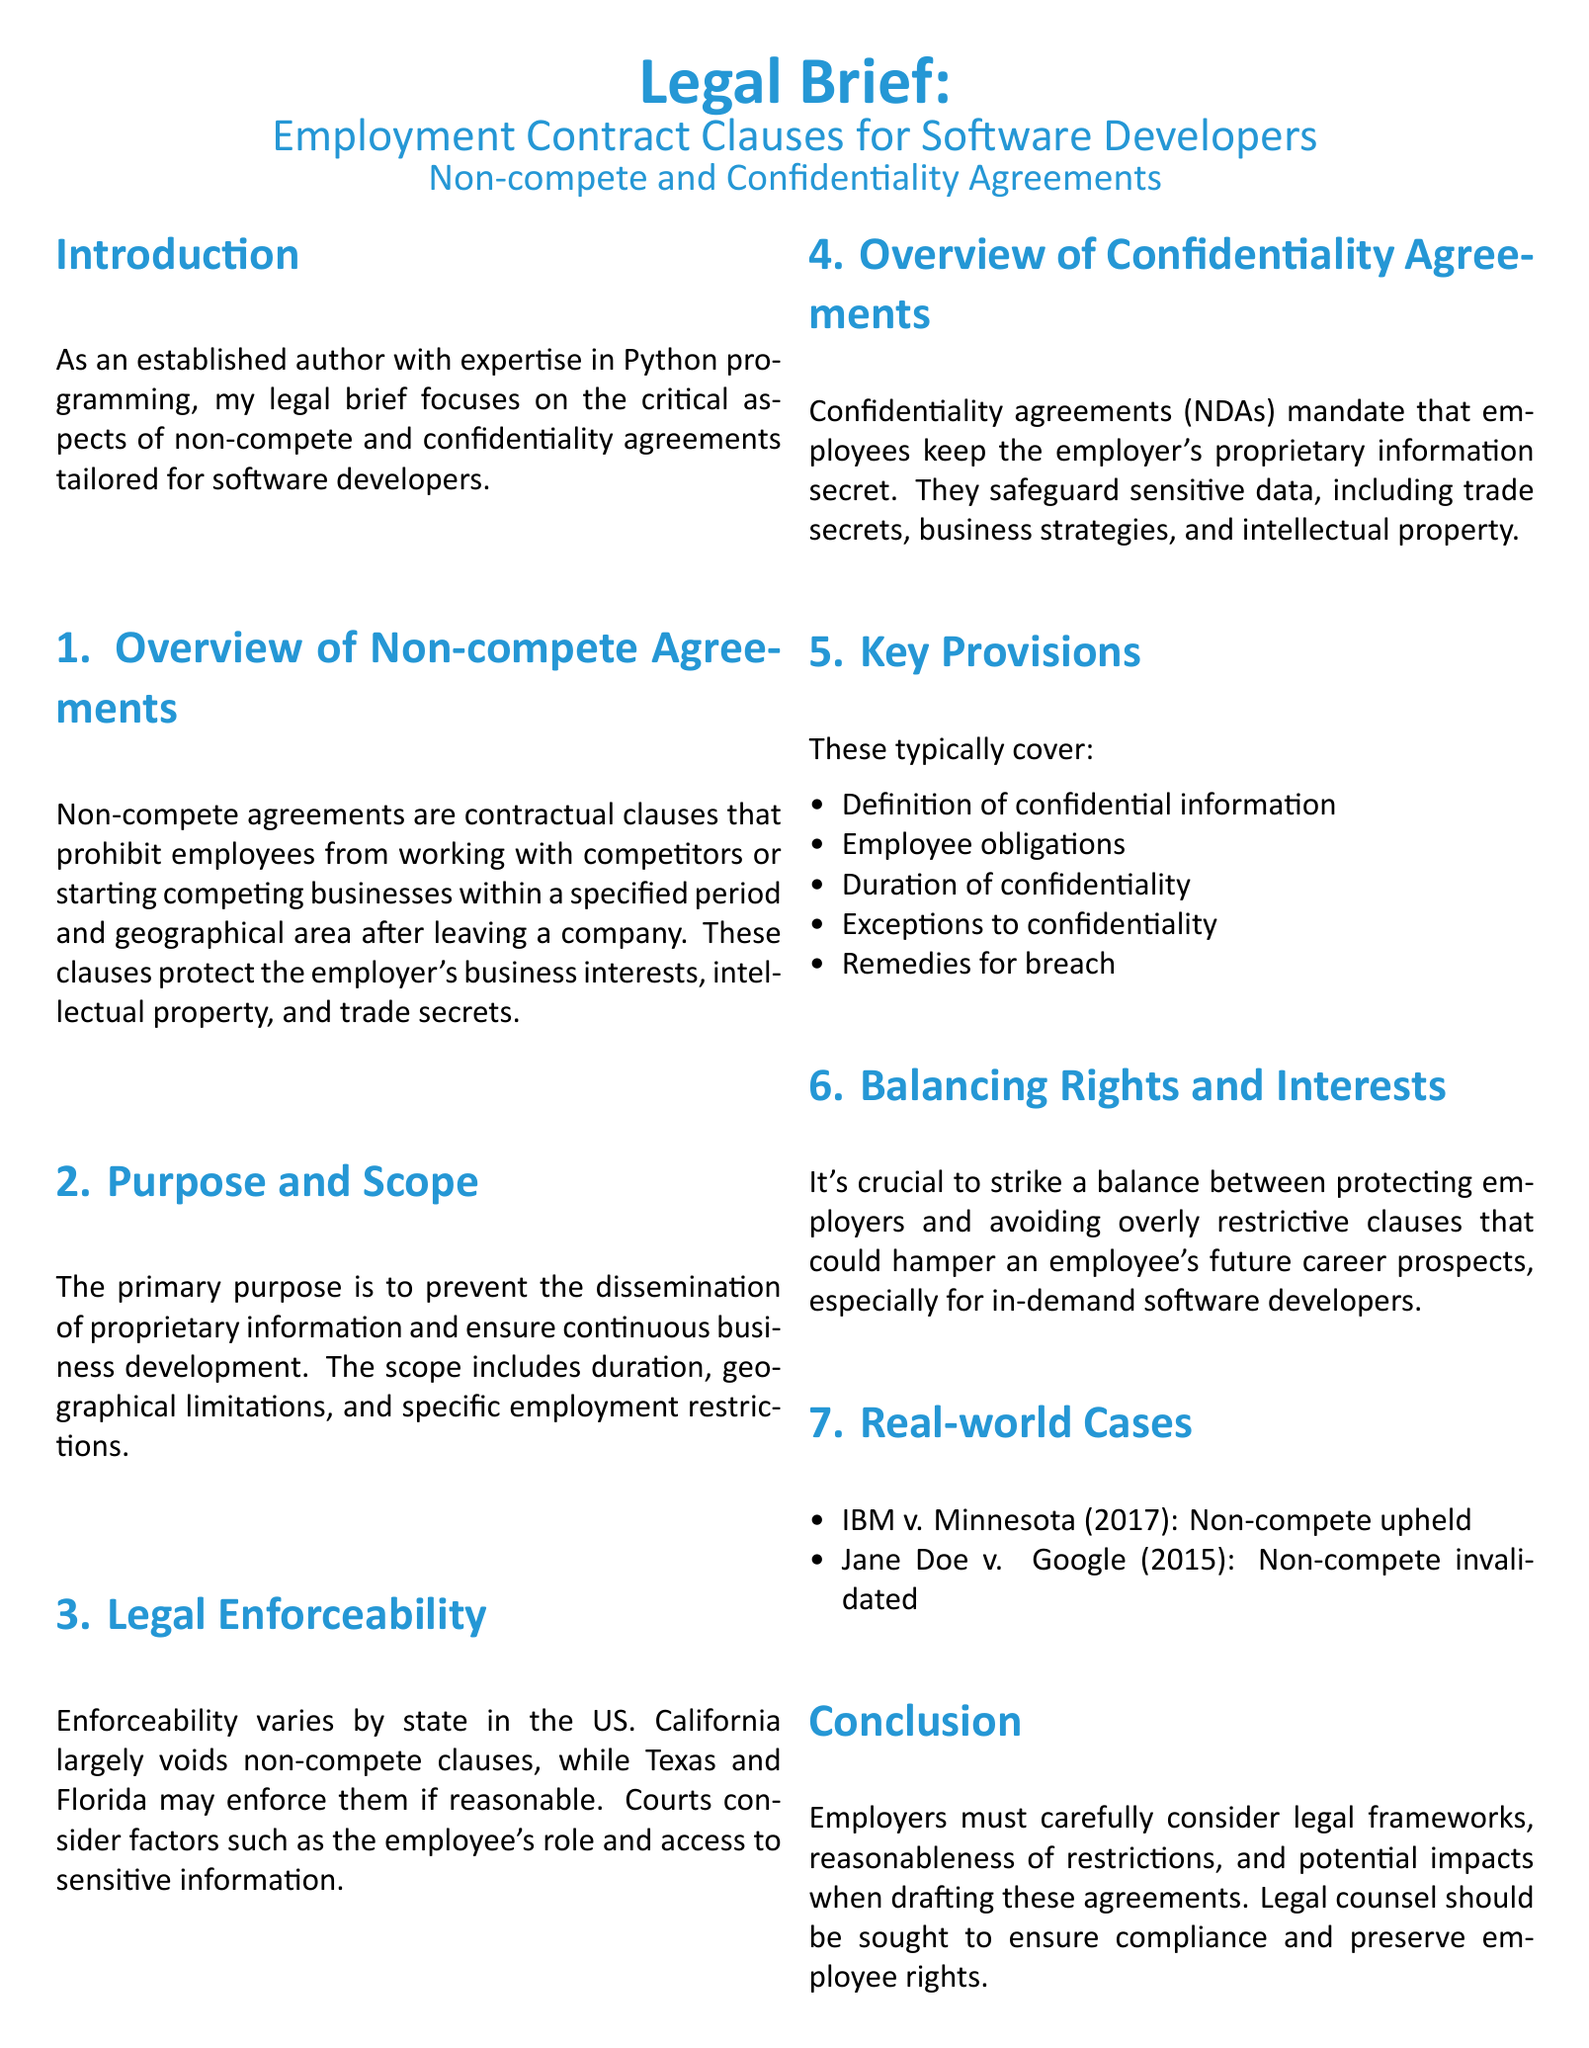What is the primary purpose of non-compete agreements? The primary purpose is to prevent the dissemination of proprietary information and ensure continuous business development.
Answer: Prevent the dissemination of proprietary information and ensure continuous business development Which state largely voids non-compete clauses? California largely voids non-compete clauses, distinguishing it from other states like Texas and Florida.
Answer: California What do confidentiality agreements mandate employees to do? Confidentiality agreements (NDAs) mandate that employees keep the employer's proprietary information secret.
Answer: Keep the employer's proprietary information secret Name one real-world case where a non-compete was upheld. IBM v. Minnesota is an example of a case where a non-compete was upheld in court.
Answer: IBM v. Minnesota What should employers consider when drafting these agreements? Employers must carefully consider legal frameworks, reasonableness of restrictions, and potential impacts when drafting these agreements.
Answer: Legal frameworks, reasonableness of restrictions, and potential impacts How many key provisions are listed for confidentiality agreements? The document lists five key provisions that are typically included in confidentiality agreements.
Answer: Five What color is the main font in the document? The document specifies the main font as Calibri.
Answer: Calibri What is the conclusion regarding compliance and employee rights? Legal counsel should be sought to ensure compliance and preserve employee rights.
Answer: Legal counsel should be sought 